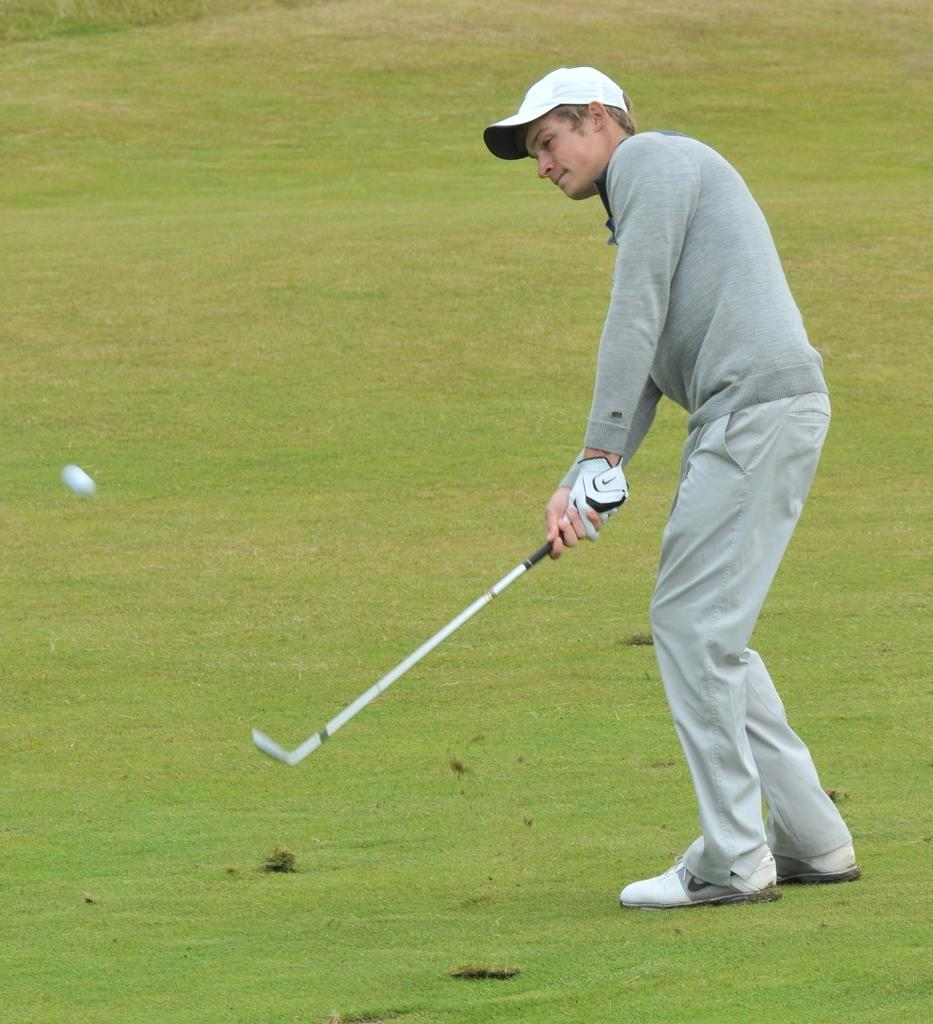What is the main subject of the image? There is a man in the image. What is the man standing on? The man is standing on a grass surface. What is the man holding in the image? The man is holding a hockey stick. What is the man doing with the hockey stick? The man is hitting a ball on the surface. What type of clothing is the man wearing on his upper body? The man is wearing a T-shirt. What type of headwear is the man wearing? The man is wearing a white cap. What type of salt can be seen in the image? There is no salt present in the image. How many weeks does the man plan to expand his business in the image? There is no indication of a business or expansion in the image; it simply shows a man playing hockey on a grass surface. 